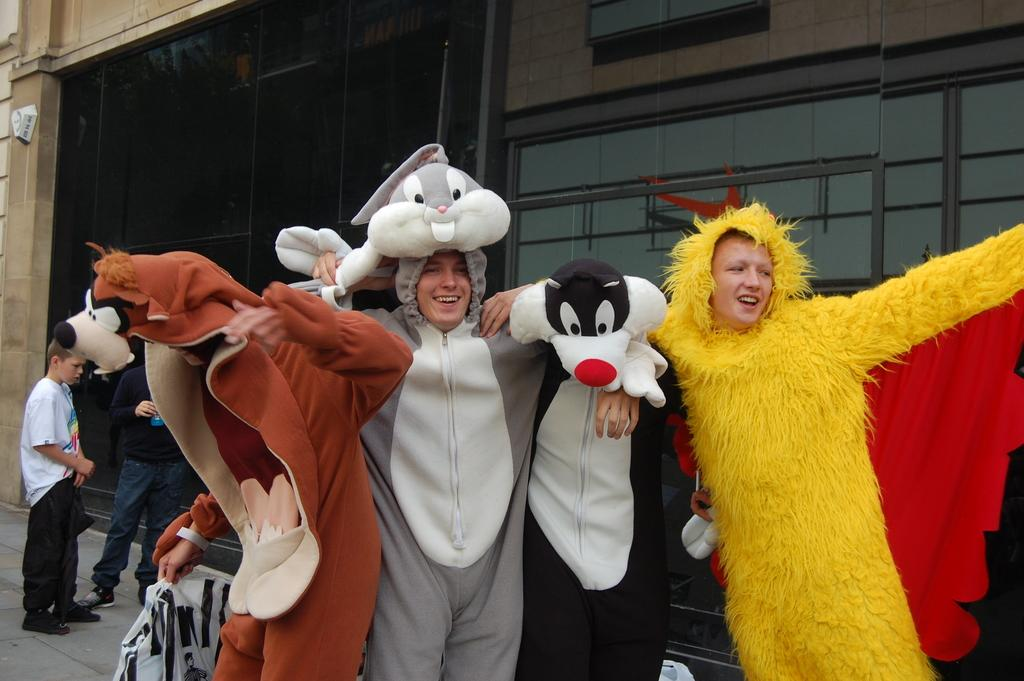How many people are in the image? There are four persons in the image. What are the four persons wearing? The four persons are wearing fancy dresses. Can you describe the background of the image? There are two persons in the background of the image, along with glasses and a wall. What type of furniture is being kicked in the image? There is no furniture present in the image, nor is anyone kicking anything. 